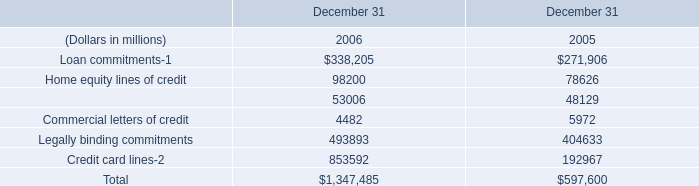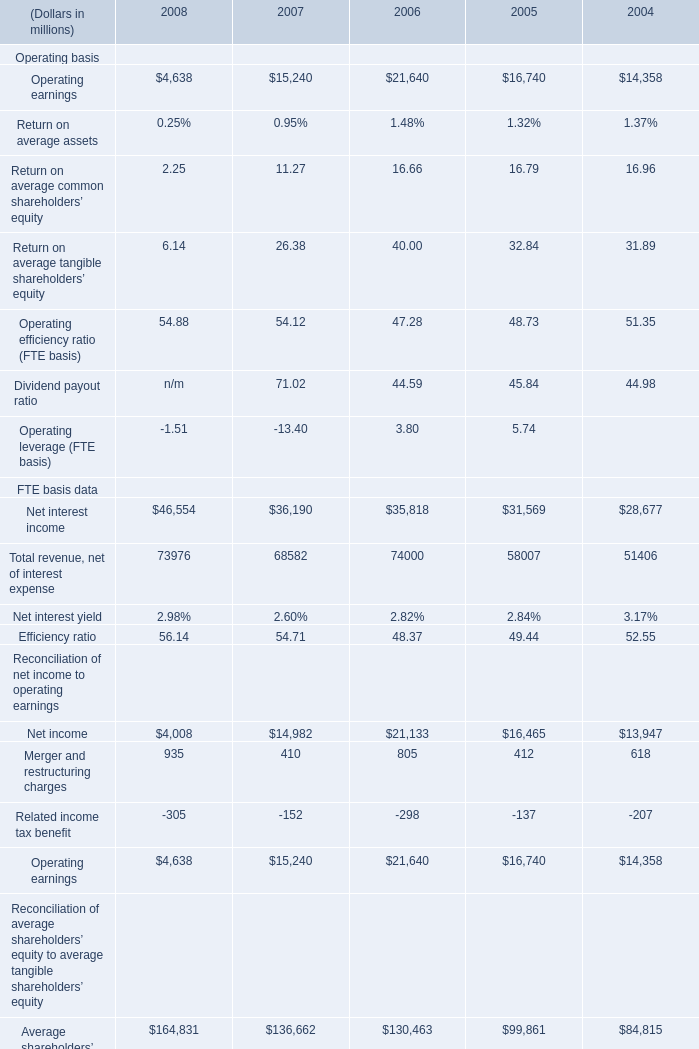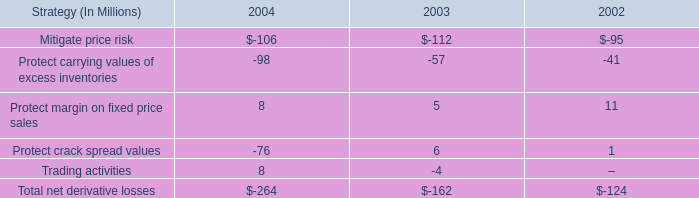what was the change in derivative gains included in ig segment income from 2004 , compared to 2003 , in millions? 
Computations: (17 - 19)
Answer: -2.0. 